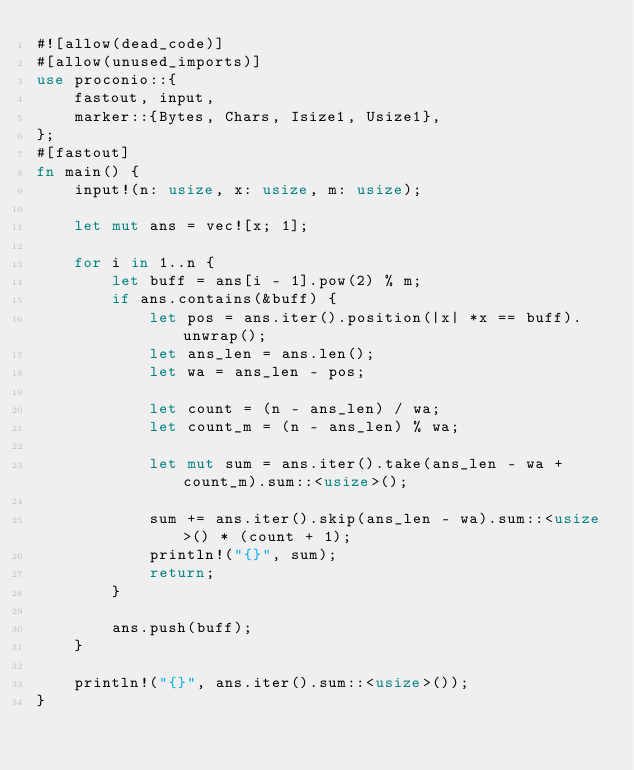<code> <loc_0><loc_0><loc_500><loc_500><_Rust_>#![allow(dead_code)]
#[allow(unused_imports)]
use proconio::{
    fastout, input,
    marker::{Bytes, Chars, Isize1, Usize1},
};
#[fastout]
fn main() {
    input!(n: usize, x: usize, m: usize);

    let mut ans = vec![x; 1];

    for i in 1..n {
        let buff = ans[i - 1].pow(2) % m;
        if ans.contains(&buff) {
            let pos = ans.iter().position(|x| *x == buff).unwrap();
            let ans_len = ans.len();
            let wa = ans_len - pos;

            let count = (n - ans_len) / wa;
            let count_m = (n - ans_len) % wa;

            let mut sum = ans.iter().take(ans_len - wa + count_m).sum::<usize>();

            sum += ans.iter().skip(ans_len - wa).sum::<usize>() * (count + 1);
            println!("{}", sum);
            return;
        }

        ans.push(buff);
    }

    println!("{}", ans.iter().sum::<usize>());
}
</code> 